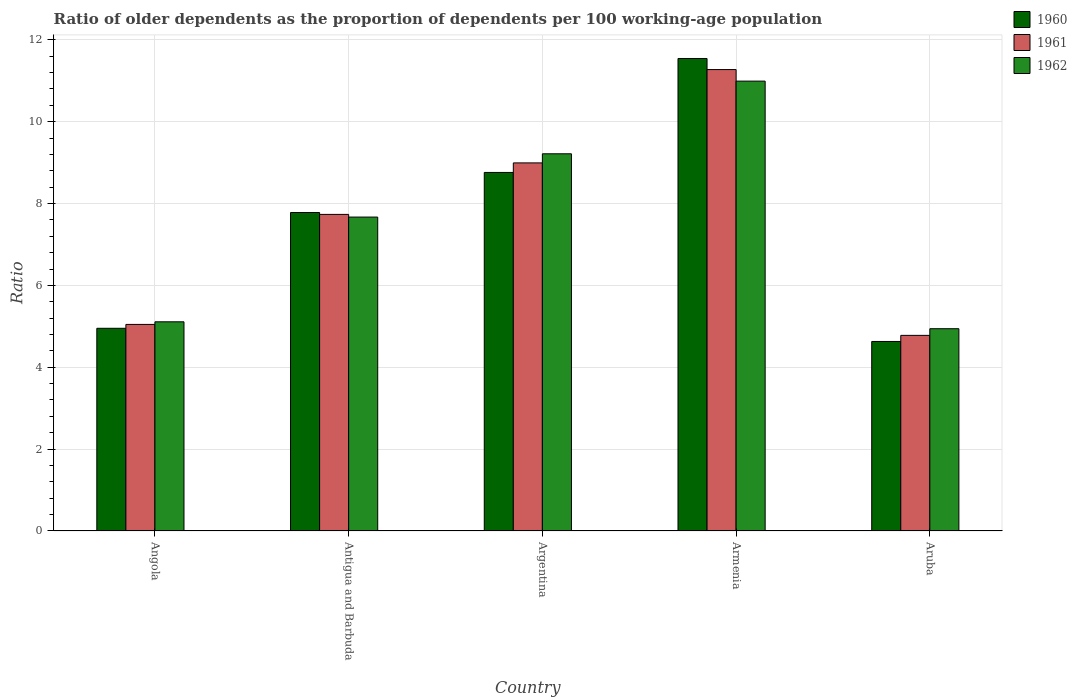How many different coloured bars are there?
Your answer should be very brief. 3. Are the number of bars on each tick of the X-axis equal?
Offer a terse response. Yes. How many bars are there on the 4th tick from the left?
Give a very brief answer. 3. How many bars are there on the 5th tick from the right?
Offer a terse response. 3. In how many cases, is the number of bars for a given country not equal to the number of legend labels?
Give a very brief answer. 0. What is the age dependency ratio(old) in 1960 in Antigua and Barbuda?
Your response must be concise. 7.78. Across all countries, what is the maximum age dependency ratio(old) in 1961?
Keep it short and to the point. 11.27. Across all countries, what is the minimum age dependency ratio(old) in 1960?
Make the answer very short. 4.63. In which country was the age dependency ratio(old) in 1960 maximum?
Provide a succinct answer. Armenia. In which country was the age dependency ratio(old) in 1962 minimum?
Provide a succinct answer. Aruba. What is the total age dependency ratio(old) in 1960 in the graph?
Keep it short and to the point. 37.66. What is the difference between the age dependency ratio(old) in 1961 in Antigua and Barbuda and that in Armenia?
Offer a very short reply. -3.54. What is the difference between the age dependency ratio(old) in 1960 in Aruba and the age dependency ratio(old) in 1962 in Antigua and Barbuda?
Offer a terse response. -3.04. What is the average age dependency ratio(old) in 1962 per country?
Offer a terse response. 7.58. What is the difference between the age dependency ratio(old) of/in 1961 and age dependency ratio(old) of/in 1960 in Aruba?
Offer a very short reply. 0.15. What is the ratio of the age dependency ratio(old) in 1962 in Antigua and Barbuda to that in Argentina?
Provide a short and direct response. 0.83. What is the difference between the highest and the second highest age dependency ratio(old) in 1961?
Provide a short and direct response. -2.28. What is the difference between the highest and the lowest age dependency ratio(old) in 1961?
Offer a very short reply. 6.49. Is the sum of the age dependency ratio(old) in 1961 in Angola and Armenia greater than the maximum age dependency ratio(old) in 1960 across all countries?
Offer a terse response. Yes. What does the 2nd bar from the left in Aruba represents?
Your answer should be compact. 1961. Is it the case that in every country, the sum of the age dependency ratio(old) in 1960 and age dependency ratio(old) in 1962 is greater than the age dependency ratio(old) in 1961?
Offer a terse response. Yes. Are all the bars in the graph horizontal?
Your answer should be very brief. No. How many countries are there in the graph?
Provide a succinct answer. 5. What is the difference between two consecutive major ticks on the Y-axis?
Provide a short and direct response. 2. Are the values on the major ticks of Y-axis written in scientific E-notation?
Offer a terse response. No. Does the graph contain grids?
Ensure brevity in your answer.  Yes. How many legend labels are there?
Offer a very short reply. 3. How are the legend labels stacked?
Your answer should be compact. Vertical. What is the title of the graph?
Make the answer very short. Ratio of older dependents as the proportion of dependents per 100 working-age population. Does "2005" appear as one of the legend labels in the graph?
Make the answer very short. No. What is the label or title of the Y-axis?
Your answer should be very brief. Ratio. What is the Ratio of 1960 in Angola?
Make the answer very short. 4.95. What is the Ratio of 1961 in Angola?
Make the answer very short. 5.05. What is the Ratio in 1962 in Angola?
Your answer should be compact. 5.11. What is the Ratio of 1960 in Antigua and Barbuda?
Offer a terse response. 7.78. What is the Ratio in 1961 in Antigua and Barbuda?
Give a very brief answer. 7.73. What is the Ratio of 1962 in Antigua and Barbuda?
Your answer should be very brief. 7.67. What is the Ratio in 1960 in Argentina?
Provide a succinct answer. 8.76. What is the Ratio in 1961 in Argentina?
Make the answer very short. 8.99. What is the Ratio in 1962 in Argentina?
Offer a terse response. 9.21. What is the Ratio in 1960 in Armenia?
Ensure brevity in your answer.  11.54. What is the Ratio of 1961 in Armenia?
Ensure brevity in your answer.  11.27. What is the Ratio of 1962 in Armenia?
Offer a terse response. 10.99. What is the Ratio of 1960 in Aruba?
Your answer should be very brief. 4.63. What is the Ratio of 1961 in Aruba?
Offer a very short reply. 4.78. What is the Ratio in 1962 in Aruba?
Give a very brief answer. 4.94. Across all countries, what is the maximum Ratio of 1960?
Your response must be concise. 11.54. Across all countries, what is the maximum Ratio of 1961?
Your answer should be compact. 11.27. Across all countries, what is the maximum Ratio in 1962?
Keep it short and to the point. 10.99. Across all countries, what is the minimum Ratio of 1960?
Offer a terse response. 4.63. Across all countries, what is the minimum Ratio of 1961?
Offer a terse response. 4.78. Across all countries, what is the minimum Ratio of 1962?
Ensure brevity in your answer.  4.94. What is the total Ratio of 1960 in the graph?
Offer a terse response. 37.66. What is the total Ratio in 1961 in the graph?
Keep it short and to the point. 37.82. What is the total Ratio in 1962 in the graph?
Offer a very short reply. 37.92. What is the difference between the Ratio in 1960 in Angola and that in Antigua and Barbuda?
Provide a succinct answer. -2.83. What is the difference between the Ratio in 1961 in Angola and that in Antigua and Barbuda?
Your response must be concise. -2.69. What is the difference between the Ratio in 1962 in Angola and that in Antigua and Barbuda?
Keep it short and to the point. -2.56. What is the difference between the Ratio of 1960 in Angola and that in Argentina?
Give a very brief answer. -3.81. What is the difference between the Ratio in 1961 in Angola and that in Argentina?
Make the answer very short. -3.95. What is the difference between the Ratio in 1962 in Angola and that in Argentina?
Your response must be concise. -4.1. What is the difference between the Ratio in 1960 in Angola and that in Armenia?
Offer a terse response. -6.59. What is the difference between the Ratio of 1961 in Angola and that in Armenia?
Give a very brief answer. -6.23. What is the difference between the Ratio of 1962 in Angola and that in Armenia?
Offer a terse response. -5.88. What is the difference between the Ratio in 1960 in Angola and that in Aruba?
Provide a short and direct response. 0.32. What is the difference between the Ratio of 1961 in Angola and that in Aruba?
Make the answer very short. 0.27. What is the difference between the Ratio of 1962 in Angola and that in Aruba?
Keep it short and to the point. 0.17. What is the difference between the Ratio of 1960 in Antigua and Barbuda and that in Argentina?
Make the answer very short. -0.98. What is the difference between the Ratio in 1961 in Antigua and Barbuda and that in Argentina?
Make the answer very short. -1.26. What is the difference between the Ratio in 1962 in Antigua and Barbuda and that in Argentina?
Offer a terse response. -1.55. What is the difference between the Ratio of 1960 in Antigua and Barbuda and that in Armenia?
Keep it short and to the point. -3.76. What is the difference between the Ratio in 1961 in Antigua and Barbuda and that in Armenia?
Keep it short and to the point. -3.54. What is the difference between the Ratio in 1962 in Antigua and Barbuda and that in Armenia?
Ensure brevity in your answer.  -3.32. What is the difference between the Ratio in 1960 in Antigua and Barbuda and that in Aruba?
Offer a terse response. 3.15. What is the difference between the Ratio in 1961 in Antigua and Barbuda and that in Aruba?
Your answer should be compact. 2.96. What is the difference between the Ratio in 1962 in Antigua and Barbuda and that in Aruba?
Ensure brevity in your answer.  2.73. What is the difference between the Ratio in 1960 in Argentina and that in Armenia?
Ensure brevity in your answer.  -2.78. What is the difference between the Ratio of 1961 in Argentina and that in Armenia?
Provide a short and direct response. -2.28. What is the difference between the Ratio of 1962 in Argentina and that in Armenia?
Provide a succinct answer. -1.78. What is the difference between the Ratio in 1960 in Argentina and that in Aruba?
Make the answer very short. 4.13. What is the difference between the Ratio in 1961 in Argentina and that in Aruba?
Your answer should be very brief. 4.21. What is the difference between the Ratio in 1962 in Argentina and that in Aruba?
Give a very brief answer. 4.27. What is the difference between the Ratio of 1960 in Armenia and that in Aruba?
Your answer should be compact. 6.91. What is the difference between the Ratio of 1961 in Armenia and that in Aruba?
Keep it short and to the point. 6.49. What is the difference between the Ratio in 1962 in Armenia and that in Aruba?
Provide a succinct answer. 6.05. What is the difference between the Ratio in 1960 in Angola and the Ratio in 1961 in Antigua and Barbuda?
Provide a succinct answer. -2.78. What is the difference between the Ratio in 1960 in Angola and the Ratio in 1962 in Antigua and Barbuda?
Your response must be concise. -2.72. What is the difference between the Ratio in 1961 in Angola and the Ratio in 1962 in Antigua and Barbuda?
Provide a short and direct response. -2.62. What is the difference between the Ratio of 1960 in Angola and the Ratio of 1961 in Argentina?
Provide a succinct answer. -4.04. What is the difference between the Ratio of 1960 in Angola and the Ratio of 1962 in Argentina?
Your answer should be compact. -4.26. What is the difference between the Ratio of 1961 in Angola and the Ratio of 1962 in Argentina?
Keep it short and to the point. -4.17. What is the difference between the Ratio in 1960 in Angola and the Ratio in 1961 in Armenia?
Keep it short and to the point. -6.32. What is the difference between the Ratio in 1960 in Angola and the Ratio in 1962 in Armenia?
Ensure brevity in your answer.  -6.04. What is the difference between the Ratio in 1961 in Angola and the Ratio in 1962 in Armenia?
Ensure brevity in your answer.  -5.94. What is the difference between the Ratio of 1960 in Angola and the Ratio of 1961 in Aruba?
Your answer should be compact. 0.17. What is the difference between the Ratio in 1960 in Angola and the Ratio in 1962 in Aruba?
Offer a terse response. 0.01. What is the difference between the Ratio of 1961 in Angola and the Ratio of 1962 in Aruba?
Offer a terse response. 0.1. What is the difference between the Ratio of 1960 in Antigua and Barbuda and the Ratio of 1961 in Argentina?
Give a very brief answer. -1.21. What is the difference between the Ratio in 1960 in Antigua and Barbuda and the Ratio in 1962 in Argentina?
Your answer should be very brief. -1.43. What is the difference between the Ratio in 1961 in Antigua and Barbuda and the Ratio in 1962 in Argentina?
Give a very brief answer. -1.48. What is the difference between the Ratio in 1960 in Antigua and Barbuda and the Ratio in 1961 in Armenia?
Your answer should be compact. -3.49. What is the difference between the Ratio in 1960 in Antigua and Barbuda and the Ratio in 1962 in Armenia?
Provide a short and direct response. -3.21. What is the difference between the Ratio of 1961 in Antigua and Barbuda and the Ratio of 1962 in Armenia?
Provide a short and direct response. -3.26. What is the difference between the Ratio of 1960 in Antigua and Barbuda and the Ratio of 1961 in Aruba?
Keep it short and to the point. 3. What is the difference between the Ratio of 1960 in Antigua and Barbuda and the Ratio of 1962 in Aruba?
Keep it short and to the point. 2.84. What is the difference between the Ratio in 1961 in Antigua and Barbuda and the Ratio in 1962 in Aruba?
Offer a terse response. 2.79. What is the difference between the Ratio of 1960 in Argentina and the Ratio of 1961 in Armenia?
Your response must be concise. -2.51. What is the difference between the Ratio in 1960 in Argentina and the Ratio in 1962 in Armenia?
Make the answer very short. -2.23. What is the difference between the Ratio of 1961 in Argentina and the Ratio of 1962 in Armenia?
Keep it short and to the point. -2. What is the difference between the Ratio of 1960 in Argentina and the Ratio of 1961 in Aruba?
Offer a terse response. 3.98. What is the difference between the Ratio of 1960 in Argentina and the Ratio of 1962 in Aruba?
Keep it short and to the point. 3.82. What is the difference between the Ratio of 1961 in Argentina and the Ratio of 1962 in Aruba?
Keep it short and to the point. 4.05. What is the difference between the Ratio in 1960 in Armenia and the Ratio in 1961 in Aruba?
Your answer should be very brief. 6.76. What is the difference between the Ratio in 1960 in Armenia and the Ratio in 1962 in Aruba?
Offer a terse response. 6.6. What is the difference between the Ratio in 1961 in Armenia and the Ratio in 1962 in Aruba?
Your response must be concise. 6.33. What is the average Ratio in 1960 per country?
Offer a very short reply. 7.53. What is the average Ratio of 1961 per country?
Provide a short and direct response. 7.56. What is the average Ratio in 1962 per country?
Ensure brevity in your answer.  7.58. What is the difference between the Ratio in 1960 and Ratio in 1961 in Angola?
Give a very brief answer. -0.09. What is the difference between the Ratio of 1960 and Ratio of 1962 in Angola?
Ensure brevity in your answer.  -0.16. What is the difference between the Ratio of 1961 and Ratio of 1962 in Angola?
Ensure brevity in your answer.  -0.06. What is the difference between the Ratio of 1960 and Ratio of 1961 in Antigua and Barbuda?
Make the answer very short. 0.05. What is the difference between the Ratio of 1960 and Ratio of 1962 in Antigua and Barbuda?
Your answer should be very brief. 0.11. What is the difference between the Ratio in 1961 and Ratio in 1962 in Antigua and Barbuda?
Make the answer very short. 0.07. What is the difference between the Ratio in 1960 and Ratio in 1961 in Argentina?
Provide a succinct answer. -0.23. What is the difference between the Ratio of 1960 and Ratio of 1962 in Argentina?
Offer a very short reply. -0.46. What is the difference between the Ratio of 1961 and Ratio of 1962 in Argentina?
Keep it short and to the point. -0.22. What is the difference between the Ratio of 1960 and Ratio of 1961 in Armenia?
Offer a terse response. 0.27. What is the difference between the Ratio in 1960 and Ratio in 1962 in Armenia?
Your response must be concise. 0.55. What is the difference between the Ratio in 1961 and Ratio in 1962 in Armenia?
Your answer should be very brief. 0.28. What is the difference between the Ratio in 1960 and Ratio in 1961 in Aruba?
Your answer should be very brief. -0.15. What is the difference between the Ratio of 1960 and Ratio of 1962 in Aruba?
Provide a succinct answer. -0.31. What is the difference between the Ratio in 1961 and Ratio in 1962 in Aruba?
Give a very brief answer. -0.16. What is the ratio of the Ratio in 1960 in Angola to that in Antigua and Barbuda?
Provide a succinct answer. 0.64. What is the ratio of the Ratio in 1961 in Angola to that in Antigua and Barbuda?
Provide a short and direct response. 0.65. What is the ratio of the Ratio in 1962 in Angola to that in Antigua and Barbuda?
Provide a succinct answer. 0.67. What is the ratio of the Ratio in 1960 in Angola to that in Argentina?
Offer a very short reply. 0.57. What is the ratio of the Ratio of 1961 in Angola to that in Argentina?
Offer a terse response. 0.56. What is the ratio of the Ratio in 1962 in Angola to that in Argentina?
Offer a terse response. 0.55. What is the ratio of the Ratio in 1960 in Angola to that in Armenia?
Ensure brevity in your answer.  0.43. What is the ratio of the Ratio in 1961 in Angola to that in Armenia?
Your answer should be compact. 0.45. What is the ratio of the Ratio in 1962 in Angola to that in Armenia?
Give a very brief answer. 0.47. What is the ratio of the Ratio in 1960 in Angola to that in Aruba?
Offer a very short reply. 1.07. What is the ratio of the Ratio of 1961 in Angola to that in Aruba?
Keep it short and to the point. 1.06. What is the ratio of the Ratio of 1962 in Angola to that in Aruba?
Keep it short and to the point. 1.03. What is the ratio of the Ratio of 1960 in Antigua and Barbuda to that in Argentina?
Your answer should be very brief. 0.89. What is the ratio of the Ratio of 1961 in Antigua and Barbuda to that in Argentina?
Your answer should be very brief. 0.86. What is the ratio of the Ratio of 1962 in Antigua and Barbuda to that in Argentina?
Your response must be concise. 0.83. What is the ratio of the Ratio in 1960 in Antigua and Barbuda to that in Armenia?
Offer a very short reply. 0.67. What is the ratio of the Ratio of 1961 in Antigua and Barbuda to that in Armenia?
Your answer should be compact. 0.69. What is the ratio of the Ratio of 1962 in Antigua and Barbuda to that in Armenia?
Offer a terse response. 0.7. What is the ratio of the Ratio of 1960 in Antigua and Barbuda to that in Aruba?
Your answer should be compact. 1.68. What is the ratio of the Ratio in 1961 in Antigua and Barbuda to that in Aruba?
Give a very brief answer. 1.62. What is the ratio of the Ratio in 1962 in Antigua and Barbuda to that in Aruba?
Your answer should be very brief. 1.55. What is the ratio of the Ratio in 1960 in Argentina to that in Armenia?
Ensure brevity in your answer.  0.76. What is the ratio of the Ratio in 1961 in Argentina to that in Armenia?
Ensure brevity in your answer.  0.8. What is the ratio of the Ratio in 1962 in Argentina to that in Armenia?
Make the answer very short. 0.84. What is the ratio of the Ratio of 1960 in Argentina to that in Aruba?
Your answer should be compact. 1.89. What is the ratio of the Ratio in 1961 in Argentina to that in Aruba?
Offer a terse response. 1.88. What is the ratio of the Ratio in 1962 in Argentina to that in Aruba?
Offer a very short reply. 1.86. What is the ratio of the Ratio of 1960 in Armenia to that in Aruba?
Your response must be concise. 2.49. What is the ratio of the Ratio of 1961 in Armenia to that in Aruba?
Keep it short and to the point. 2.36. What is the ratio of the Ratio in 1962 in Armenia to that in Aruba?
Provide a short and direct response. 2.22. What is the difference between the highest and the second highest Ratio of 1960?
Give a very brief answer. 2.78. What is the difference between the highest and the second highest Ratio in 1961?
Offer a very short reply. 2.28. What is the difference between the highest and the second highest Ratio in 1962?
Keep it short and to the point. 1.78. What is the difference between the highest and the lowest Ratio of 1960?
Offer a very short reply. 6.91. What is the difference between the highest and the lowest Ratio in 1961?
Offer a very short reply. 6.49. What is the difference between the highest and the lowest Ratio in 1962?
Offer a terse response. 6.05. 